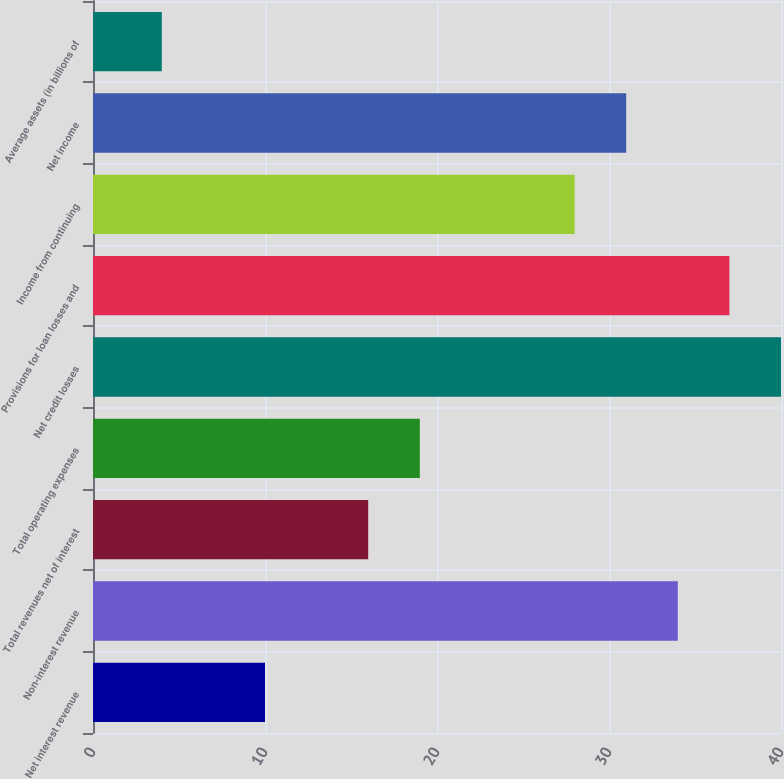Convert chart. <chart><loc_0><loc_0><loc_500><loc_500><bar_chart><fcel>Net interest revenue<fcel>Non-interest revenue<fcel>Total revenues net of interest<fcel>Total operating expenses<fcel>Net credit losses<fcel>Provisions for loan losses and<fcel>Income from continuing<fcel>Net income<fcel>Average assets (in billions of<nl><fcel>10<fcel>34<fcel>16<fcel>19<fcel>40<fcel>37<fcel>28<fcel>31<fcel>4<nl></chart> 